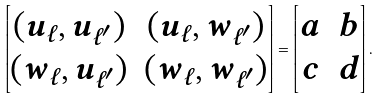Convert formula to latex. <formula><loc_0><loc_0><loc_500><loc_500>\begin{bmatrix} ( u _ { \ell } , u _ { \ell ^ { \prime } } ) & ( u _ { \ell } , w _ { \ell ^ { \prime } } ) \\ ( w _ { \ell } , u _ { \ell ^ { \prime } } ) & ( w _ { \ell } , w _ { \ell ^ { \prime } } ) \end{bmatrix} = \begin{bmatrix} a & b \\ c & d \end{bmatrix} .</formula> 